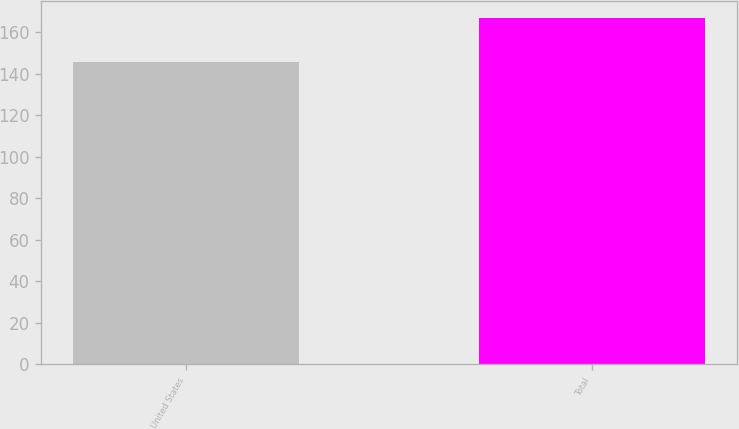<chart> <loc_0><loc_0><loc_500><loc_500><bar_chart><fcel>United States<fcel>Total<nl><fcel>146<fcel>167<nl></chart> 